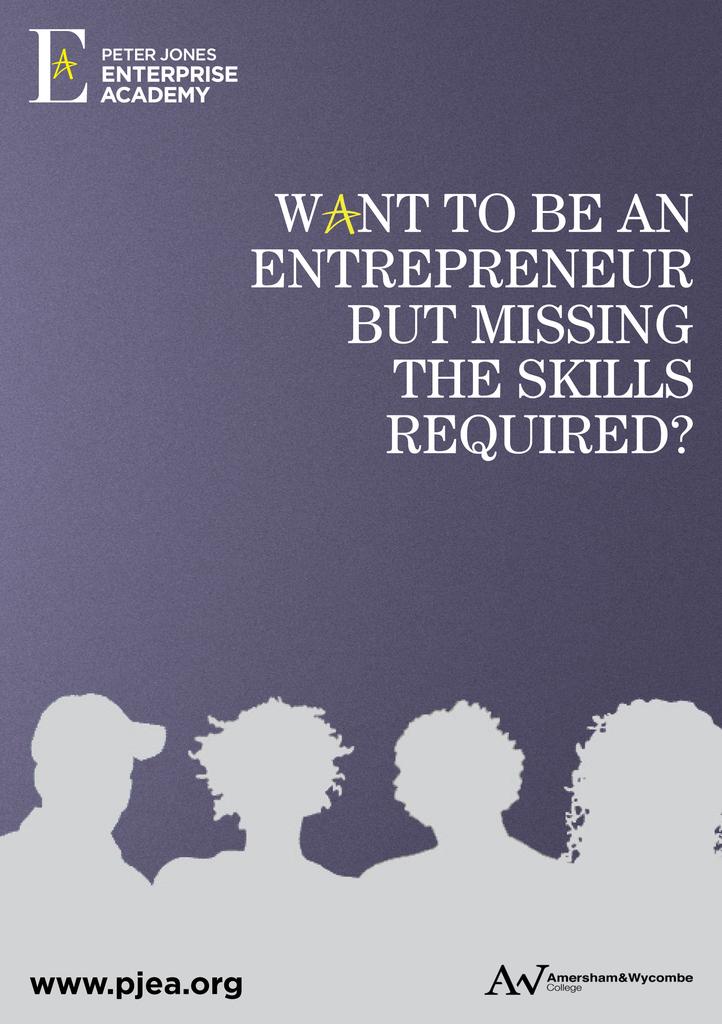What website is shown on the page?
Ensure brevity in your answer.  Www.pjea.org. What company put out this book?
Offer a terse response. Peter jones enterprise academy. 